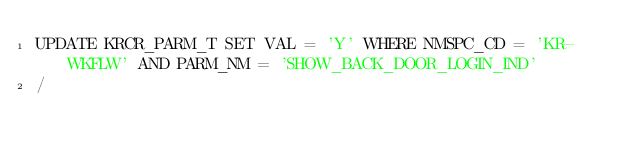<code> <loc_0><loc_0><loc_500><loc_500><_SQL_>UPDATE KRCR_PARM_T SET VAL = 'Y' WHERE NMSPC_CD = 'KR-WKFLW' AND PARM_NM = 'SHOW_BACK_DOOR_LOGIN_IND'
/
</code> 